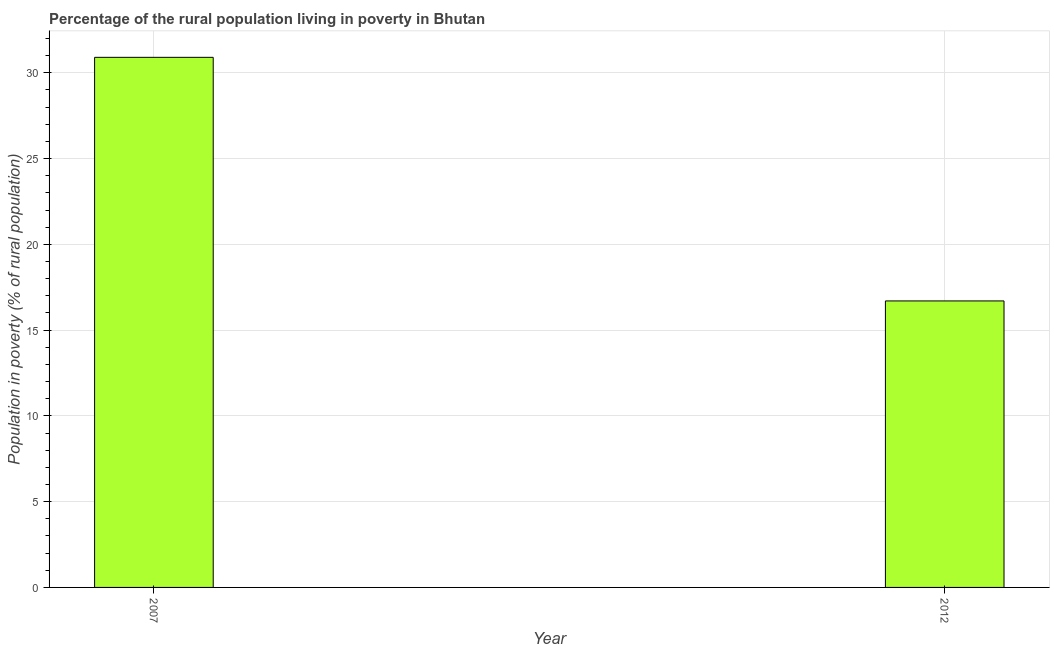What is the title of the graph?
Make the answer very short. Percentage of the rural population living in poverty in Bhutan. What is the label or title of the X-axis?
Keep it short and to the point. Year. What is the label or title of the Y-axis?
Give a very brief answer. Population in poverty (% of rural population). What is the percentage of rural population living below poverty line in 2007?
Keep it short and to the point. 30.9. Across all years, what is the maximum percentage of rural population living below poverty line?
Make the answer very short. 30.9. In which year was the percentage of rural population living below poverty line maximum?
Your response must be concise. 2007. In which year was the percentage of rural population living below poverty line minimum?
Provide a succinct answer. 2012. What is the sum of the percentage of rural population living below poverty line?
Give a very brief answer. 47.6. What is the difference between the percentage of rural population living below poverty line in 2007 and 2012?
Give a very brief answer. 14.2. What is the average percentage of rural population living below poverty line per year?
Make the answer very short. 23.8. What is the median percentage of rural population living below poverty line?
Make the answer very short. 23.8. Do a majority of the years between 2007 and 2012 (inclusive) have percentage of rural population living below poverty line greater than 17 %?
Ensure brevity in your answer.  No. What is the ratio of the percentage of rural population living below poverty line in 2007 to that in 2012?
Your response must be concise. 1.85. In how many years, is the percentage of rural population living below poverty line greater than the average percentage of rural population living below poverty line taken over all years?
Your answer should be compact. 1. How many bars are there?
Your answer should be compact. 2. Are all the bars in the graph horizontal?
Your answer should be very brief. No. How many years are there in the graph?
Offer a very short reply. 2. What is the difference between two consecutive major ticks on the Y-axis?
Ensure brevity in your answer.  5. Are the values on the major ticks of Y-axis written in scientific E-notation?
Give a very brief answer. No. What is the Population in poverty (% of rural population) of 2007?
Make the answer very short. 30.9. What is the Population in poverty (% of rural population) in 2012?
Your answer should be very brief. 16.7. What is the difference between the Population in poverty (% of rural population) in 2007 and 2012?
Provide a succinct answer. 14.2. What is the ratio of the Population in poverty (% of rural population) in 2007 to that in 2012?
Your answer should be compact. 1.85. 